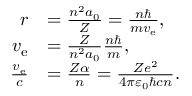Convert formula to latex. <formula><loc_0><loc_0><loc_500><loc_500>{ \begin{array} { r l } { r } & { = { \frac { n ^ { 2 } a _ { 0 } } { Z } } = { \frac { n } { m v _ { e } } } , } \\ { v _ { e } } & { = { \frac { Z } { n ^ { 2 } a _ { 0 } } } { \frac { n } { m } } , } \\ { { \frac { v _ { e } } { c } } } & { = { \frac { Z \alpha } { n } } = { \frac { Z e ^ { 2 } } { 4 \pi \varepsilon _ { 0 } \hbar { c } n } } . } \end{array} }</formula> 